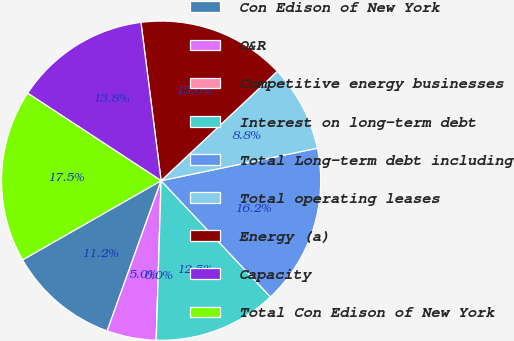Convert chart to OTSL. <chart><loc_0><loc_0><loc_500><loc_500><pie_chart><fcel>Con Edison of New York<fcel>O&R<fcel>Competitive energy businesses<fcel>Interest on long-term debt<fcel>Total Long-term debt including<fcel>Total operating leases<fcel>Energy (a)<fcel>Capacity<fcel>Total Con Edison of New York<nl><fcel>11.25%<fcel>5.0%<fcel>0.0%<fcel>12.5%<fcel>16.25%<fcel>8.75%<fcel>15.0%<fcel>13.75%<fcel>17.5%<nl></chart> 